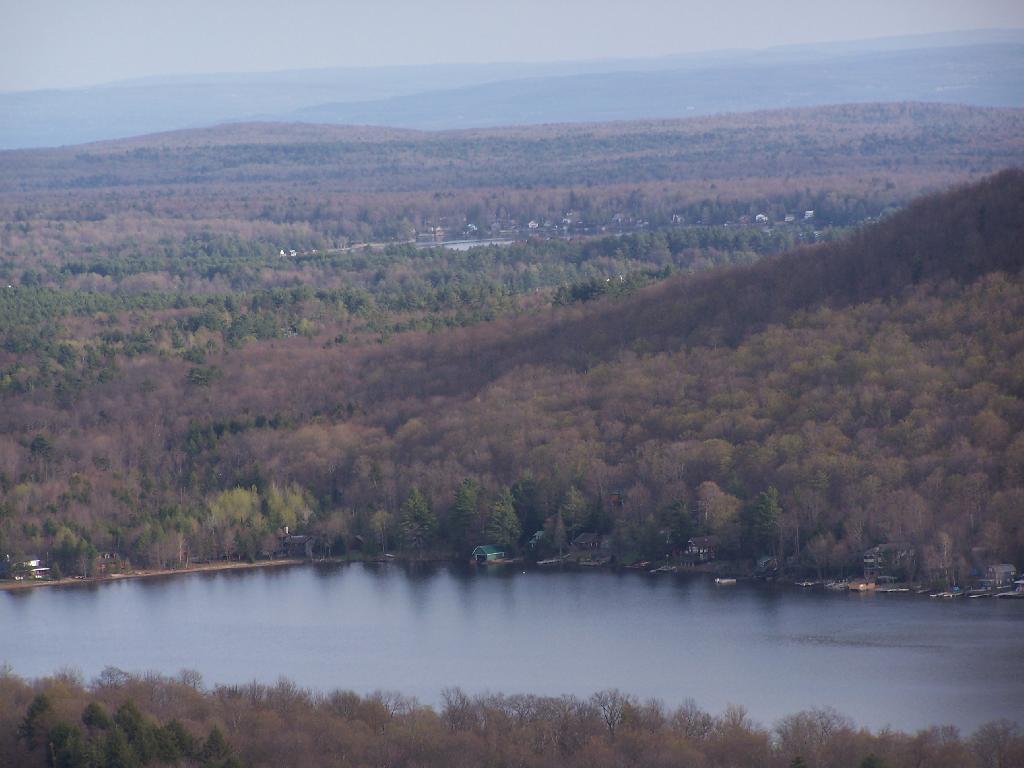In one or two sentences, can you explain what this image depicts? In this picture we can see trees and water, beside the water we can see sheds and some objects and in the background we can see mountains, sky. 